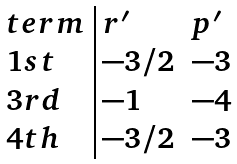<formula> <loc_0><loc_0><loc_500><loc_500>\begin{array} { l | l l } t e r m & r ^ { \prime } & p ^ { \prime } \\ 1 s t & - 3 / 2 & - 3 \\ 3 r d & - 1 & - 4 \\ 4 t h & - 3 / 2 & - 3 \end{array}</formula> 